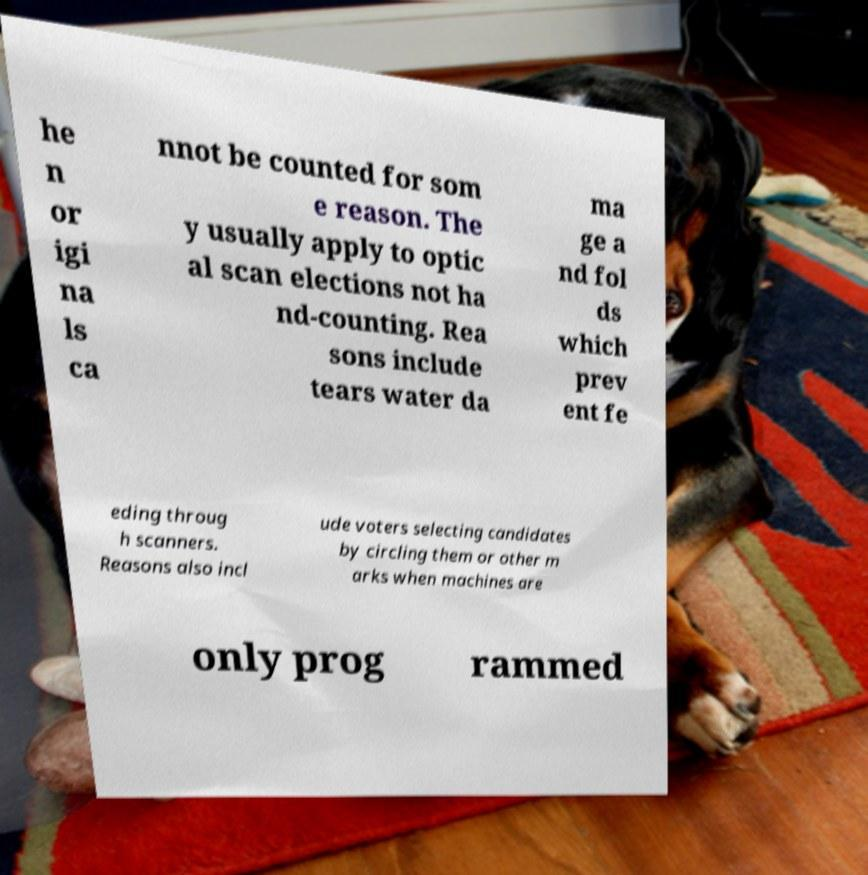Please identify and transcribe the text found in this image. he n or igi na ls ca nnot be counted for som e reason. The y usually apply to optic al scan elections not ha nd-counting. Rea sons include tears water da ma ge a nd fol ds which prev ent fe eding throug h scanners. Reasons also incl ude voters selecting candidates by circling them or other m arks when machines are only prog rammed 